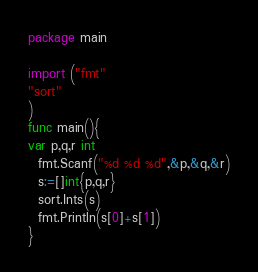Convert code to text. <code><loc_0><loc_0><loc_500><loc_500><_Go_>package main

import ("fmt"
"sort"
)
func main(){
var p,q,r int
  fmt.Scanf("%d %d %d",&p,&q,&r)
  s:=[]int{p,q,r}
  sort.Ints(s)
  fmt.Println(s[0]+s[1])
}</code> 